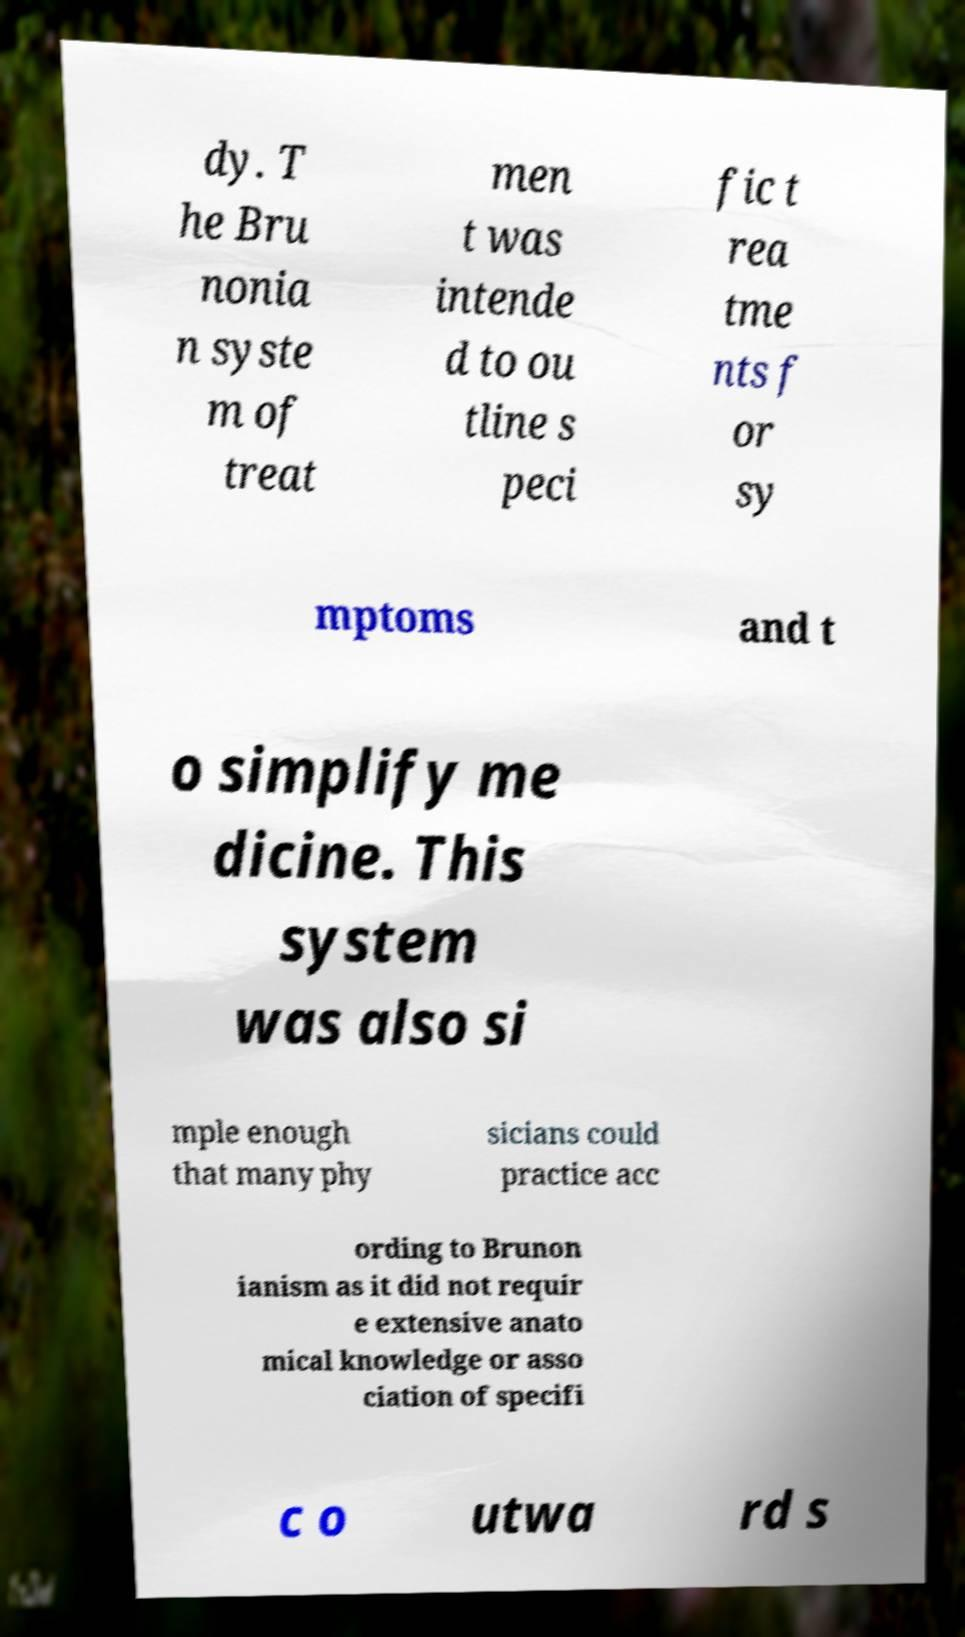There's text embedded in this image that I need extracted. Can you transcribe it verbatim? dy. T he Bru nonia n syste m of treat men t was intende d to ou tline s peci fic t rea tme nts f or sy mptoms and t o simplify me dicine. This system was also si mple enough that many phy sicians could practice acc ording to Brunon ianism as it did not requir e extensive anato mical knowledge or asso ciation of specifi c o utwa rd s 